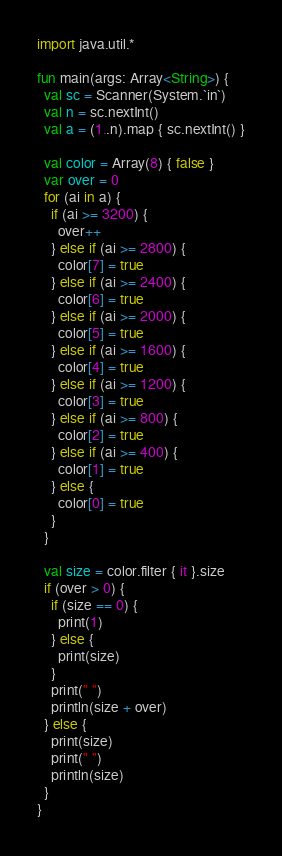Convert code to text. <code><loc_0><loc_0><loc_500><loc_500><_Kotlin_>import java.util.*

fun main(args: Array<String>) {
  val sc = Scanner(System.`in`)
  val n = sc.nextInt()
  val a = (1..n).map { sc.nextInt() }

  val color = Array(8) { false }
  var over = 0
  for (ai in a) {
    if (ai >= 3200) {
      over++
    } else if (ai >= 2800) {
      color[7] = true
    } else if (ai >= 2400) {
      color[6] = true
    } else if (ai >= 2000) {
      color[5] = true
    } else if (ai >= 1600) {
      color[4] = true
    } else if (ai >= 1200) {
      color[3] = true
    } else if (ai >= 800) {
      color[2] = true
    } else if (ai >= 400) {
      color[1] = true
    } else {
      color[0] = true
    }
  }

  val size = color.filter { it }.size
  if (over > 0) {
    if (size == 0) {
      print(1)
    } else {
      print(size)
    }
    print(" ")
    println(size + over)
  } else {
    print(size)
    print(" ")
    println(size)
  }
}
</code> 